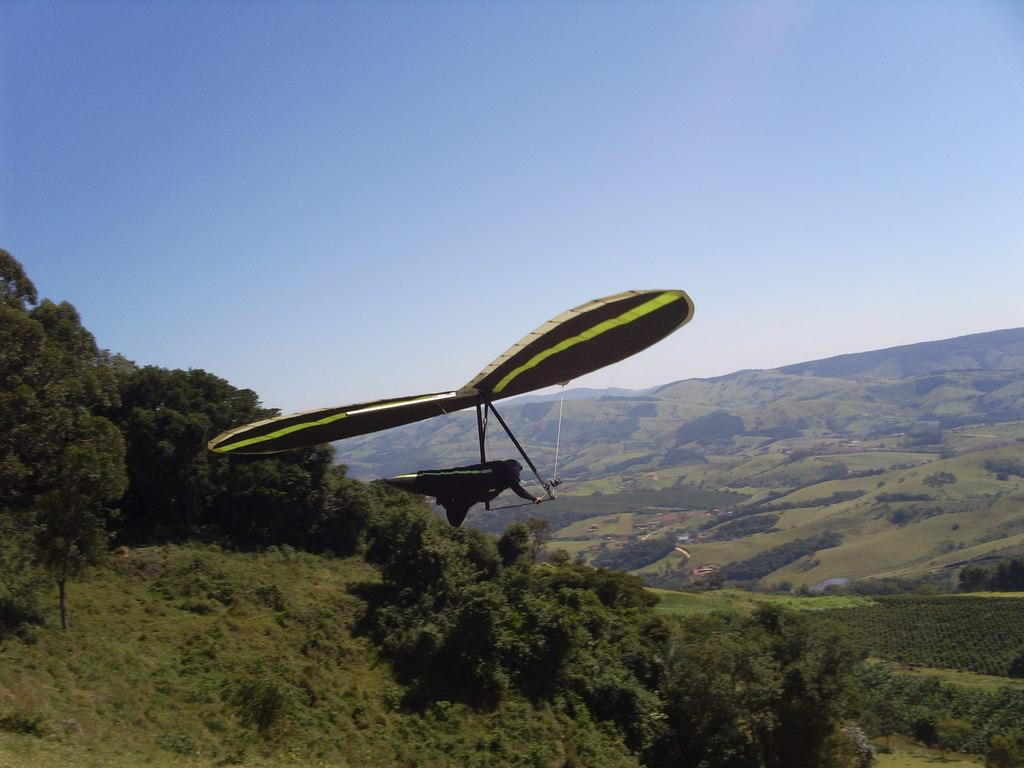What type of aircraft is shown in the image? There is a powered hang glider in the image. What can be seen in the background of the image? There are trees in the image. Where was the image taken? The image was clicked outside. What is visible at the top of the image? The sky is visible at the top of the image. How many legs does the powered hang glider have in the image? The powered hang glider does not have legs; it has a structure that supports its wings and a motor for propulsion. 